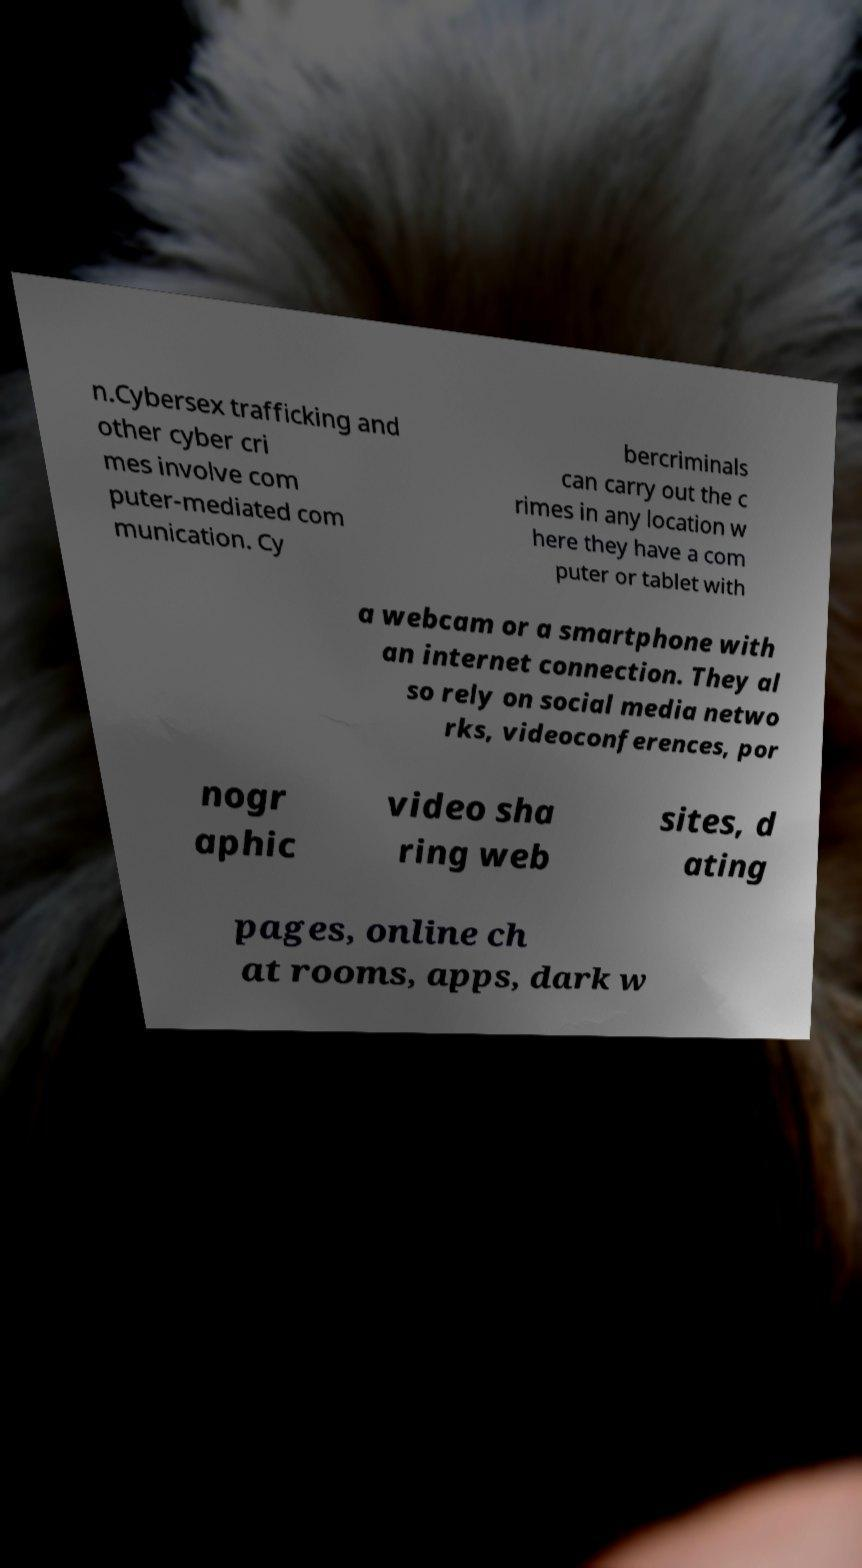Can you read and provide the text displayed in the image?This photo seems to have some interesting text. Can you extract and type it out for me? n.Cybersex trafficking and other cyber cri mes involve com puter-mediated com munication. Cy bercriminals can carry out the c rimes in any location w here they have a com puter or tablet with a webcam or a smartphone with an internet connection. They al so rely on social media netwo rks, videoconferences, por nogr aphic video sha ring web sites, d ating pages, online ch at rooms, apps, dark w 